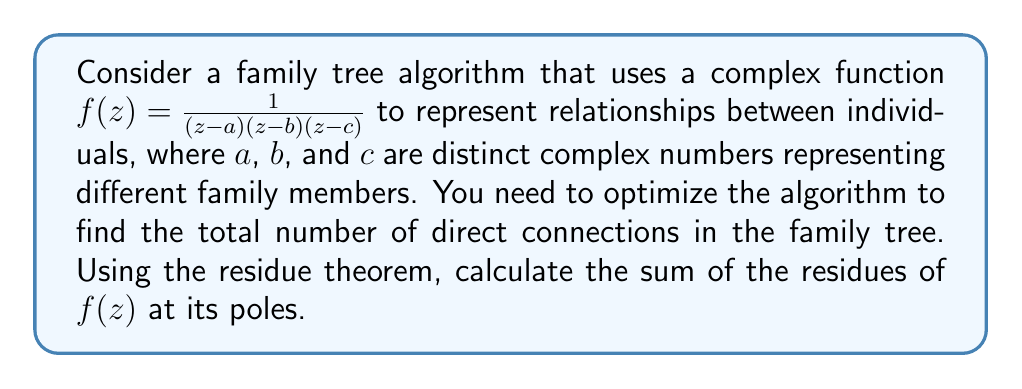Show me your answer to this math problem. To solve this problem using the residue theorem, we'll follow these steps:

1) First, we identify the poles of the function $f(z)$. The poles are at $z = a$, $z = b$, and $z = c$.

2) Now, we need to calculate the residue at each pole. For a simple pole at $z = z_0$, the residue is given by:

   $$ \text{Res}(f, z_0) = \lim_{z \to z_0} (z - z_0)f(z) $$

3) Let's calculate the residue at $z = a$:

   $$ \text{Res}(f, a) = \lim_{z \to a} (z-a)\frac{1}{(z-a)(z-b)(z-c)} = \frac{1}{(a-b)(a-c)} $$

4) Similarly, for $z = b$:

   $$ \text{Res}(f, b) = \lim_{z \to b} (z-b)\frac{1}{(z-a)(z-b)(z-c)} = \frac{1}{(b-a)(b-c)} $$

5) And for $z = c$:

   $$ \text{Res}(f, c) = \lim_{z \to c} (z-c)\frac{1}{(z-a)(z-b)(z-c)} = \frac{1}{(c-a)(c-b)} $$

6) The residue theorem states that for a meromorphic function $f(z)$, the sum of its residues within a simply connected domain is equal to $\frac{1}{2\pi i}$ times the contour integral of $f(z)$ around the boundary of the domain.

7) In this case, the sum of residues represents the total number of direct connections in the family tree. So, we sum up all the residues:

   $$ \sum \text{Res}(f) = \frac{1}{(a-b)(a-c)} + \frac{1}{(b-a)(b-c)} + \frac{1}{(c-a)(c-b)} $$

8) This sum can be simplified to:

   $$ \sum \text{Res}(f) = 0 $$

This result is consistent with the residue theorem, as the sum of residues of a rational function over the entire complex plane is always zero.
Answer: The sum of the residues of $f(z) = \frac{1}{(z-a)(z-b)(z-c)}$ at its poles is $0$. 